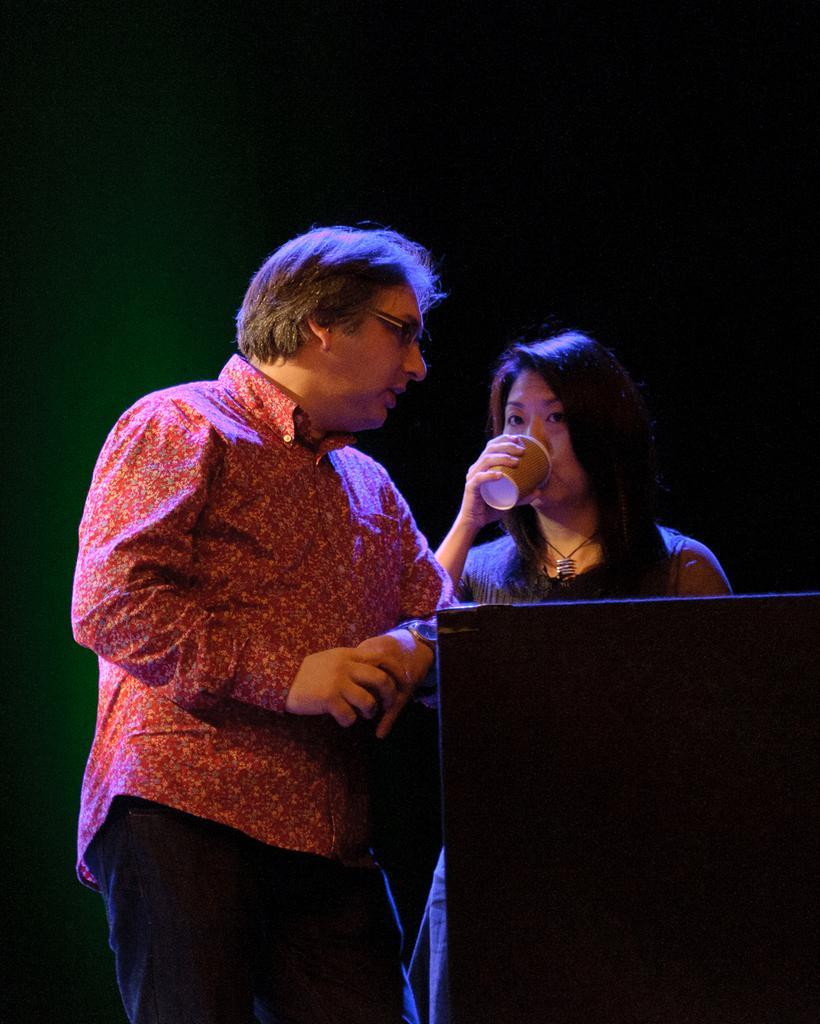Describe this image in one or two sentences. Here a man is standing, he wore a shirt, trouser beside him there is a woman standing and drinking with the glass. 